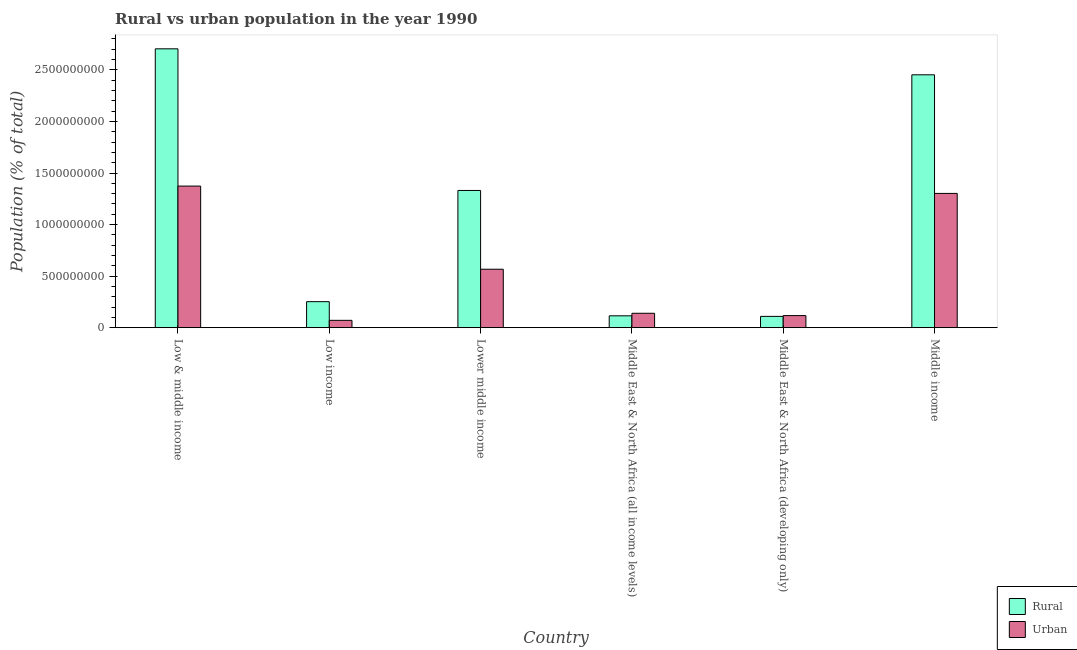Are the number of bars on each tick of the X-axis equal?
Give a very brief answer. Yes. How many bars are there on the 4th tick from the right?
Offer a terse response. 2. What is the label of the 3rd group of bars from the left?
Keep it short and to the point. Lower middle income. What is the urban population density in Lower middle income?
Your response must be concise. 5.67e+08. Across all countries, what is the maximum urban population density?
Make the answer very short. 1.37e+09. Across all countries, what is the minimum urban population density?
Give a very brief answer. 7.11e+07. What is the total urban population density in the graph?
Provide a succinct answer. 3.57e+09. What is the difference between the urban population density in Low income and that in Lower middle income?
Ensure brevity in your answer.  -4.96e+08. What is the difference between the rural population density in Low & middle income and the urban population density in Middle East & North Africa (all income levels)?
Make the answer very short. 2.57e+09. What is the average urban population density per country?
Your answer should be very brief. 5.95e+08. What is the difference between the rural population density and urban population density in Low & middle income?
Keep it short and to the point. 1.33e+09. In how many countries, is the urban population density greater than 1400000000 %?
Provide a succinct answer. 0. What is the ratio of the rural population density in Middle East & North Africa (all income levels) to that in Middle income?
Offer a very short reply. 0.05. What is the difference between the highest and the second highest rural population density?
Your response must be concise. 2.52e+08. What is the difference between the highest and the lowest rural population density?
Provide a succinct answer. 2.60e+09. Is the sum of the rural population density in Low income and Lower middle income greater than the maximum urban population density across all countries?
Offer a terse response. Yes. What does the 2nd bar from the left in Middle East & North Africa (developing only) represents?
Offer a terse response. Urban. What does the 1st bar from the right in Low income represents?
Give a very brief answer. Urban. Are all the bars in the graph horizontal?
Your response must be concise. No. Are the values on the major ticks of Y-axis written in scientific E-notation?
Offer a terse response. No. Does the graph contain any zero values?
Your answer should be compact. No. Where does the legend appear in the graph?
Your answer should be compact. Bottom right. How many legend labels are there?
Provide a short and direct response. 2. What is the title of the graph?
Keep it short and to the point. Rural vs urban population in the year 1990. Does "Working only" appear as one of the legend labels in the graph?
Offer a terse response. No. What is the label or title of the X-axis?
Your answer should be compact. Country. What is the label or title of the Y-axis?
Make the answer very short. Population (% of total). What is the Population (% of total) in Rural in Low & middle income?
Your answer should be very brief. 2.70e+09. What is the Population (% of total) of Urban in Low & middle income?
Your answer should be very brief. 1.37e+09. What is the Population (% of total) of Rural in Low income?
Keep it short and to the point. 2.52e+08. What is the Population (% of total) of Urban in Low income?
Your response must be concise. 7.11e+07. What is the Population (% of total) in Rural in Lower middle income?
Offer a very short reply. 1.33e+09. What is the Population (% of total) in Urban in Lower middle income?
Keep it short and to the point. 5.67e+08. What is the Population (% of total) of Rural in Middle East & North Africa (all income levels)?
Offer a very short reply. 1.15e+08. What is the Population (% of total) of Urban in Middle East & North Africa (all income levels)?
Give a very brief answer. 1.40e+08. What is the Population (% of total) in Rural in Middle East & North Africa (developing only)?
Your answer should be compact. 1.09e+08. What is the Population (% of total) in Urban in Middle East & North Africa (developing only)?
Offer a very short reply. 1.17e+08. What is the Population (% of total) in Rural in Middle income?
Make the answer very short. 2.45e+09. What is the Population (% of total) of Urban in Middle income?
Keep it short and to the point. 1.30e+09. Across all countries, what is the maximum Population (% of total) in Rural?
Your answer should be compact. 2.70e+09. Across all countries, what is the maximum Population (% of total) of Urban?
Keep it short and to the point. 1.37e+09. Across all countries, what is the minimum Population (% of total) of Rural?
Make the answer very short. 1.09e+08. Across all countries, what is the minimum Population (% of total) of Urban?
Provide a succinct answer. 7.11e+07. What is the total Population (% of total) in Rural in the graph?
Offer a terse response. 6.96e+09. What is the total Population (% of total) in Urban in the graph?
Provide a short and direct response. 3.57e+09. What is the difference between the Population (% of total) in Rural in Low & middle income and that in Low income?
Offer a terse response. 2.45e+09. What is the difference between the Population (% of total) of Urban in Low & middle income and that in Low income?
Your answer should be very brief. 1.30e+09. What is the difference between the Population (% of total) of Rural in Low & middle income and that in Lower middle income?
Your answer should be very brief. 1.37e+09. What is the difference between the Population (% of total) of Urban in Low & middle income and that in Lower middle income?
Your answer should be compact. 8.06e+08. What is the difference between the Population (% of total) in Rural in Low & middle income and that in Middle East & North Africa (all income levels)?
Ensure brevity in your answer.  2.59e+09. What is the difference between the Population (% of total) in Urban in Low & middle income and that in Middle East & North Africa (all income levels)?
Offer a terse response. 1.23e+09. What is the difference between the Population (% of total) of Rural in Low & middle income and that in Middle East & North Africa (developing only)?
Keep it short and to the point. 2.60e+09. What is the difference between the Population (% of total) of Urban in Low & middle income and that in Middle East & North Africa (developing only)?
Your response must be concise. 1.26e+09. What is the difference between the Population (% of total) of Rural in Low & middle income and that in Middle income?
Offer a terse response. 2.52e+08. What is the difference between the Population (% of total) in Urban in Low & middle income and that in Middle income?
Provide a succinct answer. 7.11e+07. What is the difference between the Population (% of total) of Rural in Low income and that in Lower middle income?
Give a very brief answer. -1.08e+09. What is the difference between the Population (% of total) in Urban in Low income and that in Lower middle income?
Provide a short and direct response. -4.96e+08. What is the difference between the Population (% of total) of Rural in Low income and that in Middle East & North Africa (all income levels)?
Your response must be concise. 1.37e+08. What is the difference between the Population (% of total) in Urban in Low income and that in Middle East & North Africa (all income levels)?
Give a very brief answer. -6.84e+07. What is the difference between the Population (% of total) in Rural in Low income and that in Middle East & North Africa (developing only)?
Ensure brevity in your answer.  1.43e+08. What is the difference between the Population (% of total) of Urban in Low income and that in Middle East & North Africa (developing only)?
Give a very brief answer. -4.58e+07. What is the difference between the Population (% of total) in Rural in Low income and that in Middle income?
Your answer should be very brief. -2.20e+09. What is the difference between the Population (% of total) of Urban in Low income and that in Middle income?
Offer a very short reply. -1.23e+09. What is the difference between the Population (% of total) of Rural in Lower middle income and that in Middle East & North Africa (all income levels)?
Provide a succinct answer. 1.22e+09. What is the difference between the Population (% of total) in Urban in Lower middle income and that in Middle East & North Africa (all income levels)?
Offer a very short reply. 4.27e+08. What is the difference between the Population (% of total) of Rural in Lower middle income and that in Middle East & North Africa (developing only)?
Give a very brief answer. 1.22e+09. What is the difference between the Population (% of total) in Urban in Lower middle income and that in Middle East & North Africa (developing only)?
Make the answer very short. 4.50e+08. What is the difference between the Population (% of total) in Rural in Lower middle income and that in Middle income?
Offer a terse response. -1.12e+09. What is the difference between the Population (% of total) of Urban in Lower middle income and that in Middle income?
Provide a succinct answer. -7.35e+08. What is the difference between the Population (% of total) in Rural in Middle East & North Africa (all income levels) and that in Middle East & North Africa (developing only)?
Provide a short and direct response. 5.44e+06. What is the difference between the Population (% of total) in Urban in Middle East & North Africa (all income levels) and that in Middle East & North Africa (developing only)?
Provide a succinct answer. 2.26e+07. What is the difference between the Population (% of total) in Rural in Middle East & North Africa (all income levels) and that in Middle income?
Provide a succinct answer. -2.34e+09. What is the difference between the Population (% of total) in Urban in Middle East & North Africa (all income levels) and that in Middle income?
Provide a short and direct response. -1.16e+09. What is the difference between the Population (% of total) in Rural in Middle East & North Africa (developing only) and that in Middle income?
Keep it short and to the point. -2.34e+09. What is the difference between the Population (% of total) in Urban in Middle East & North Africa (developing only) and that in Middle income?
Keep it short and to the point. -1.19e+09. What is the difference between the Population (% of total) in Rural in Low & middle income and the Population (% of total) in Urban in Low income?
Provide a short and direct response. 2.63e+09. What is the difference between the Population (% of total) of Rural in Low & middle income and the Population (% of total) of Urban in Lower middle income?
Your answer should be very brief. 2.14e+09. What is the difference between the Population (% of total) of Rural in Low & middle income and the Population (% of total) of Urban in Middle East & North Africa (all income levels)?
Offer a very short reply. 2.57e+09. What is the difference between the Population (% of total) in Rural in Low & middle income and the Population (% of total) in Urban in Middle East & North Africa (developing only)?
Make the answer very short. 2.59e+09. What is the difference between the Population (% of total) in Rural in Low & middle income and the Population (% of total) in Urban in Middle income?
Provide a short and direct response. 1.40e+09. What is the difference between the Population (% of total) in Rural in Low income and the Population (% of total) in Urban in Lower middle income?
Ensure brevity in your answer.  -3.15e+08. What is the difference between the Population (% of total) in Rural in Low income and the Population (% of total) in Urban in Middle East & North Africa (all income levels)?
Give a very brief answer. 1.13e+08. What is the difference between the Population (% of total) of Rural in Low income and the Population (% of total) of Urban in Middle East & North Africa (developing only)?
Give a very brief answer. 1.35e+08. What is the difference between the Population (% of total) of Rural in Low income and the Population (% of total) of Urban in Middle income?
Ensure brevity in your answer.  -1.05e+09. What is the difference between the Population (% of total) in Rural in Lower middle income and the Population (% of total) in Urban in Middle East & North Africa (all income levels)?
Your answer should be very brief. 1.19e+09. What is the difference between the Population (% of total) of Rural in Lower middle income and the Population (% of total) of Urban in Middle East & North Africa (developing only)?
Offer a very short reply. 1.21e+09. What is the difference between the Population (% of total) in Rural in Lower middle income and the Population (% of total) in Urban in Middle income?
Provide a succinct answer. 2.87e+07. What is the difference between the Population (% of total) of Rural in Middle East & North Africa (all income levels) and the Population (% of total) of Urban in Middle East & North Africa (developing only)?
Provide a short and direct response. -2.09e+06. What is the difference between the Population (% of total) in Rural in Middle East & North Africa (all income levels) and the Population (% of total) in Urban in Middle income?
Offer a terse response. -1.19e+09. What is the difference between the Population (% of total) in Rural in Middle East & North Africa (developing only) and the Population (% of total) in Urban in Middle income?
Your answer should be compact. -1.19e+09. What is the average Population (% of total) of Rural per country?
Provide a succinct answer. 1.16e+09. What is the average Population (% of total) in Urban per country?
Ensure brevity in your answer.  5.95e+08. What is the difference between the Population (% of total) in Rural and Population (% of total) in Urban in Low & middle income?
Ensure brevity in your answer.  1.33e+09. What is the difference between the Population (% of total) of Rural and Population (% of total) of Urban in Low income?
Provide a short and direct response. 1.81e+08. What is the difference between the Population (% of total) of Rural and Population (% of total) of Urban in Lower middle income?
Your answer should be compact. 7.64e+08. What is the difference between the Population (% of total) in Rural and Population (% of total) in Urban in Middle East & North Africa (all income levels)?
Your answer should be compact. -2.47e+07. What is the difference between the Population (% of total) in Rural and Population (% of total) in Urban in Middle East & North Africa (developing only)?
Your answer should be compact. -7.53e+06. What is the difference between the Population (% of total) in Rural and Population (% of total) in Urban in Middle income?
Offer a very short reply. 1.15e+09. What is the ratio of the Population (% of total) of Rural in Low & middle income to that in Low income?
Offer a very short reply. 10.73. What is the ratio of the Population (% of total) of Urban in Low & middle income to that in Low income?
Make the answer very short. 19.3. What is the ratio of the Population (% of total) of Rural in Low & middle income to that in Lower middle income?
Make the answer very short. 2.03. What is the ratio of the Population (% of total) in Urban in Low & middle income to that in Lower middle income?
Keep it short and to the point. 2.42. What is the ratio of the Population (% of total) of Rural in Low & middle income to that in Middle East & North Africa (all income levels)?
Offer a terse response. 23.55. What is the ratio of the Population (% of total) in Urban in Low & middle income to that in Middle East & North Africa (all income levels)?
Your answer should be very brief. 9.84. What is the ratio of the Population (% of total) of Rural in Low & middle income to that in Middle East & North Africa (developing only)?
Ensure brevity in your answer.  24.72. What is the ratio of the Population (% of total) in Urban in Low & middle income to that in Middle East & North Africa (developing only)?
Provide a succinct answer. 11.74. What is the ratio of the Population (% of total) of Rural in Low & middle income to that in Middle income?
Offer a terse response. 1.1. What is the ratio of the Population (% of total) in Urban in Low & middle income to that in Middle income?
Ensure brevity in your answer.  1.05. What is the ratio of the Population (% of total) of Rural in Low income to that in Lower middle income?
Give a very brief answer. 0.19. What is the ratio of the Population (% of total) of Urban in Low income to that in Lower middle income?
Your answer should be very brief. 0.13. What is the ratio of the Population (% of total) in Rural in Low income to that in Middle East & North Africa (all income levels)?
Your answer should be compact. 2.2. What is the ratio of the Population (% of total) of Urban in Low income to that in Middle East & North Africa (all income levels)?
Ensure brevity in your answer.  0.51. What is the ratio of the Population (% of total) in Rural in Low income to that in Middle East & North Africa (developing only)?
Ensure brevity in your answer.  2.3. What is the ratio of the Population (% of total) in Urban in Low income to that in Middle East & North Africa (developing only)?
Give a very brief answer. 0.61. What is the ratio of the Population (% of total) in Rural in Low income to that in Middle income?
Give a very brief answer. 0.1. What is the ratio of the Population (% of total) in Urban in Low income to that in Middle income?
Provide a succinct answer. 0.05. What is the ratio of the Population (% of total) in Rural in Lower middle income to that in Middle East & North Africa (all income levels)?
Provide a short and direct response. 11.59. What is the ratio of the Population (% of total) of Urban in Lower middle income to that in Middle East & North Africa (all income levels)?
Give a very brief answer. 4.06. What is the ratio of the Population (% of total) in Rural in Lower middle income to that in Middle East & North Africa (developing only)?
Your answer should be very brief. 12.17. What is the ratio of the Population (% of total) in Urban in Lower middle income to that in Middle East & North Africa (developing only)?
Ensure brevity in your answer.  4.85. What is the ratio of the Population (% of total) of Rural in Lower middle income to that in Middle income?
Make the answer very short. 0.54. What is the ratio of the Population (% of total) in Urban in Lower middle income to that in Middle income?
Ensure brevity in your answer.  0.44. What is the ratio of the Population (% of total) in Rural in Middle East & North Africa (all income levels) to that in Middle East & North Africa (developing only)?
Your answer should be very brief. 1.05. What is the ratio of the Population (% of total) in Urban in Middle East & North Africa (all income levels) to that in Middle East & North Africa (developing only)?
Give a very brief answer. 1.19. What is the ratio of the Population (% of total) of Rural in Middle East & North Africa (all income levels) to that in Middle income?
Your answer should be very brief. 0.05. What is the ratio of the Population (% of total) in Urban in Middle East & North Africa (all income levels) to that in Middle income?
Offer a terse response. 0.11. What is the ratio of the Population (% of total) in Rural in Middle East & North Africa (developing only) to that in Middle income?
Give a very brief answer. 0.04. What is the ratio of the Population (% of total) of Urban in Middle East & North Africa (developing only) to that in Middle income?
Your answer should be compact. 0.09. What is the difference between the highest and the second highest Population (% of total) of Rural?
Give a very brief answer. 2.52e+08. What is the difference between the highest and the second highest Population (% of total) in Urban?
Ensure brevity in your answer.  7.11e+07. What is the difference between the highest and the lowest Population (% of total) of Rural?
Give a very brief answer. 2.60e+09. What is the difference between the highest and the lowest Population (% of total) in Urban?
Ensure brevity in your answer.  1.30e+09. 